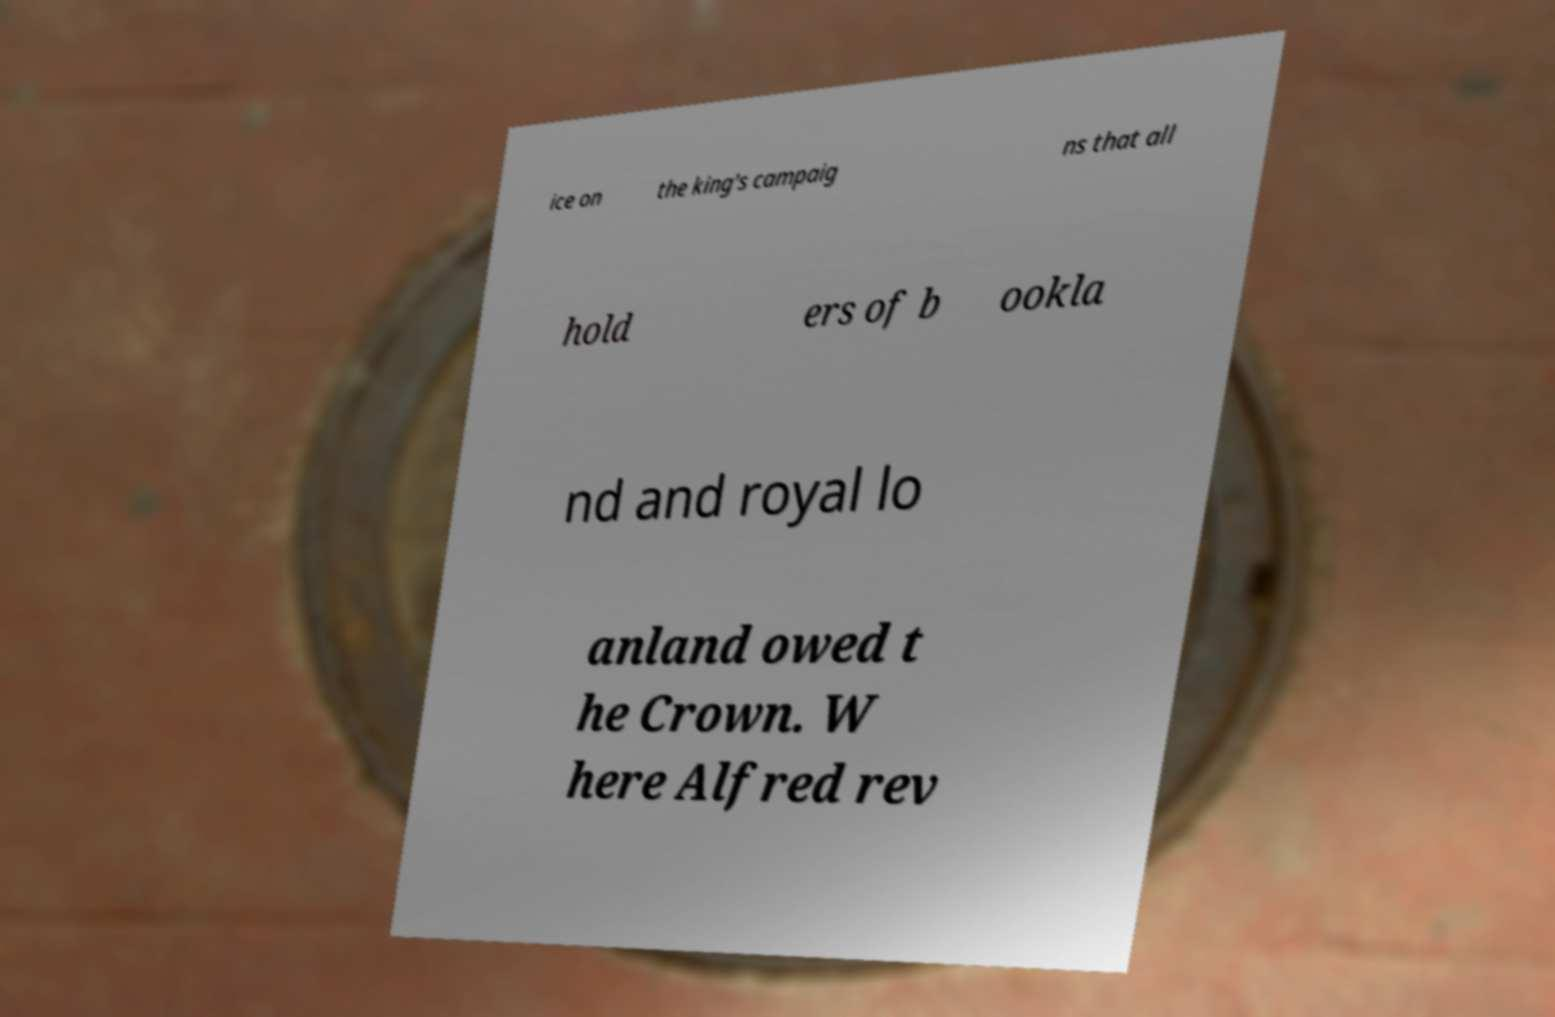Can you read and provide the text displayed in the image?This photo seems to have some interesting text. Can you extract and type it out for me? ice on the king's campaig ns that all hold ers of b ookla nd and royal lo anland owed t he Crown. W here Alfred rev 